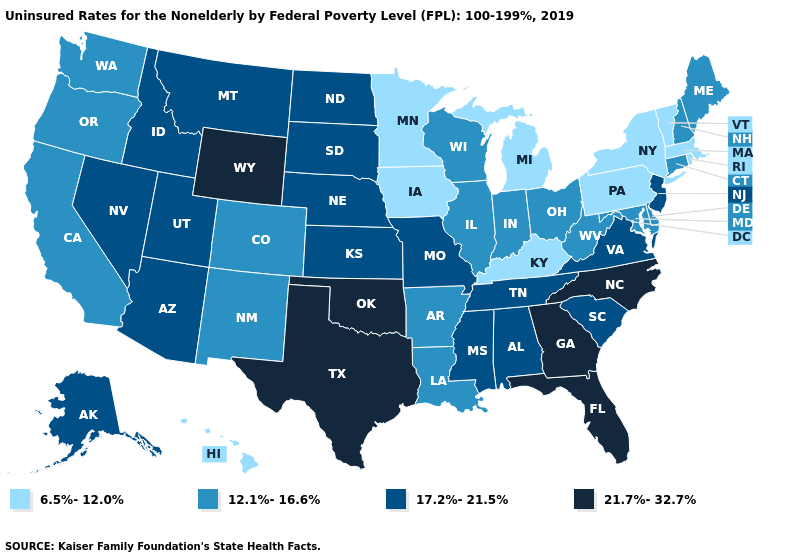What is the value of Maryland?
Short answer required. 12.1%-16.6%. Name the states that have a value in the range 17.2%-21.5%?
Give a very brief answer. Alabama, Alaska, Arizona, Idaho, Kansas, Mississippi, Missouri, Montana, Nebraska, Nevada, New Jersey, North Dakota, South Carolina, South Dakota, Tennessee, Utah, Virginia. Does Arizona have a lower value than Maine?
Be succinct. No. Name the states that have a value in the range 6.5%-12.0%?
Short answer required. Hawaii, Iowa, Kentucky, Massachusetts, Michigan, Minnesota, New York, Pennsylvania, Rhode Island, Vermont. Name the states that have a value in the range 12.1%-16.6%?
Quick response, please. Arkansas, California, Colorado, Connecticut, Delaware, Illinois, Indiana, Louisiana, Maine, Maryland, New Hampshire, New Mexico, Ohio, Oregon, Washington, West Virginia, Wisconsin. What is the lowest value in the USA?
Concise answer only. 6.5%-12.0%. Name the states that have a value in the range 21.7%-32.7%?
Write a very short answer. Florida, Georgia, North Carolina, Oklahoma, Texas, Wyoming. Which states have the lowest value in the USA?
Answer briefly. Hawaii, Iowa, Kentucky, Massachusetts, Michigan, Minnesota, New York, Pennsylvania, Rhode Island, Vermont. Name the states that have a value in the range 21.7%-32.7%?
Concise answer only. Florida, Georgia, North Carolina, Oklahoma, Texas, Wyoming. What is the lowest value in the USA?
Answer briefly. 6.5%-12.0%. Name the states that have a value in the range 6.5%-12.0%?
Quick response, please. Hawaii, Iowa, Kentucky, Massachusetts, Michigan, Minnesota, New York, Pennsylvania, Rhode Island, Vermont. Does Texas have a lower value than Colorado?
Concise answer only. No. Does Connecticut have a higher value than Alabama?
Answer briefly. No. Among the states that border Rhode Island , which have the highest value?
Keep it brief. Connecticut. Does Utah have the same value as New Jersey?
Give a very brief answer. Yes. 